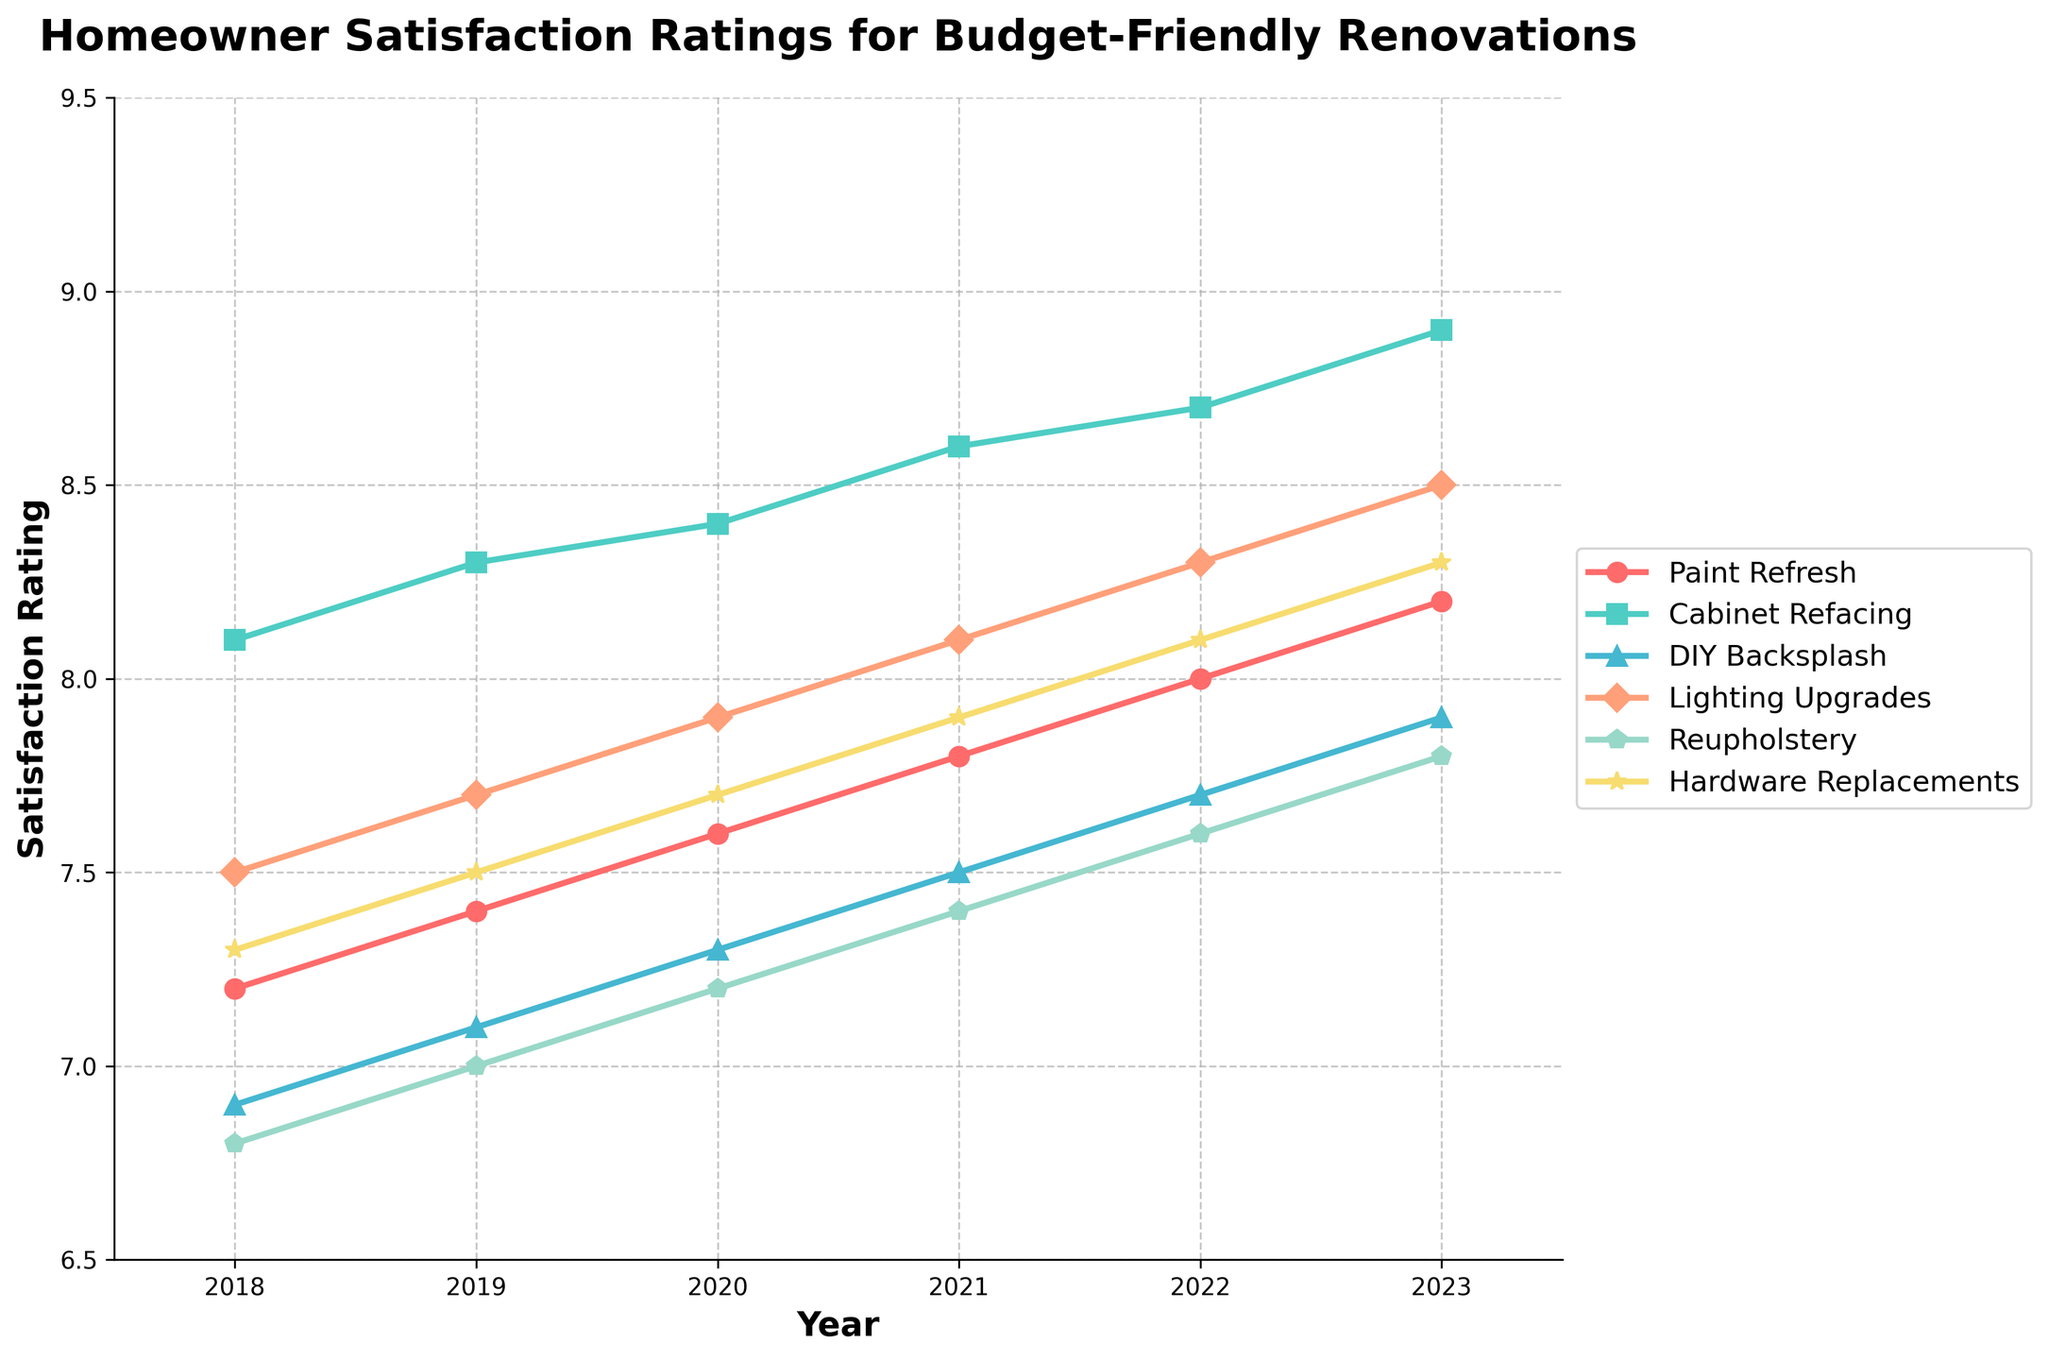What's the trend of homeowner satisfaction for DIY Backsplash from 2018 to 2023? By observing the data points for DIY Backsplash over the years 2018 to 2023, you can see an increasing trend. The satisfaction rating goes from 6.9 in 2018 to 7.9 in 2023, with a steady increase each year.
Answer: Increasing Comparing 2020 and 2023, which budget-friendly renovation technique had the greatest increase in satisfaction rating? By subtracting the 2020 ratings from the 2023 ratings for each technique, we find:
- Paint Refresh: 8.2 - 7.6 = 0.6
- Cabinet Refacing: 8.9 - 8.4 = 0.5
- DIY Backsplash: 7.9 - 7.3 = 0.6
- Lighting Upgrades: 8.5 - 7.9 = 0.6
- Reupholstery: 7.8 - 7.2 = 0.6
- Hardware Replacements: 8.3 - 7.7 = 0.6
Paint Refresh, DIY Backsplash, Lighting Upgrades, Reupholstery, and Hardware Replacements all had an equal and greatest increase of 0.6.
Answer: Paint Refresh, DIY Backsplash, Lighting Upgrades, Reupholstery, Hardware Replacements Which renovation technique had the highest satisfaction rating in 2022? By looking at the data points for 2022, Cabinet Refacing had the highest satisfaction rating of 8.7.
Answer: Cabinet Refacing What is the average satisfaction rating for Lighting Upgrades over the 6-year period? To find the average, sum the ratings for Lighting Upgrades from 2018 to 2023 and divide by the number of years:
(7.5 + 7.7 + 7.9 + 8.1 + 8.3 + 8.5) / 6 = 48.0 / 6 = 8.0
Answer: 8.0 Which renovation technique showed the most significant improvement from 2018 to 2023? By calculating the difference between the ratings in 2023 and 2018 for each technique:
- Paint Refresh: 8.2 - 7.2 = 1.0
- Cabinet Refacing: 8.9 - 8.1 = 0.8
- DIY Backsplash: 7.9 - 6.9 = 1.0
- Lighting Upgrades: 8.5 - 7.5 = 1.0
- Reupholstery: 7.8 - 6.8 = 1.0
- Hardware Replacements: 8.3 - 7.3 = 1.0
All techniques showed an improvement of 1.0, except Cabinet Refacing, which showed 0.8. Therefore, multiple techniques showed the most significant improvement of 1.0.
Answer: Paint Refresh, DIY Backsplash, Lighting Upgrades, Reupholstery, Hardware Replacements What color represents the Paint Refresh trend in the chart? By referring to the legend, the Paint Refresh trend is represented with the color red.
Answer: Red From 2018 to 2023, which two techniques had the closest final satisfaction ratings in 2023? By comparing the 2023 satisfaction ratings:
- Paint Refresh: 8.2
- Cabinet Refacing: 8.9
- DIY Backsplash: 7.9
- Lighting Upgrades: 8.5
- Reupholstery: 7.8
- Hardware Replacements: 8.3
The closest ratings are Paint Refresh (8.2) and Hardware Replacements (8.3).
Answer: Paint Refresh and Hardware Replacements What is the difference in satisfaction ratings between Reupholstery and Cabinet Refacing in 2021? By subtracting the 2021 Reupholstery rating from the 2021 Cabinet Refacing rating: 
8.6 - 7.4 = 1.2
Answer: 1.2 Which renovation technique consistently increased in satisfaction rating each year from 2018 to 2023? By reviewing the data for consistency:
- Paint Refresh: increased each year
- Cabinet Refacing: increased each year
- DIY Backsplash: increased each year
- Lighting Upgrades: increased each year
- Reupholstery: increased each year
- Hardware Replacements: increased each year
All techniques consistently increased each year.
Answer: All techniques 